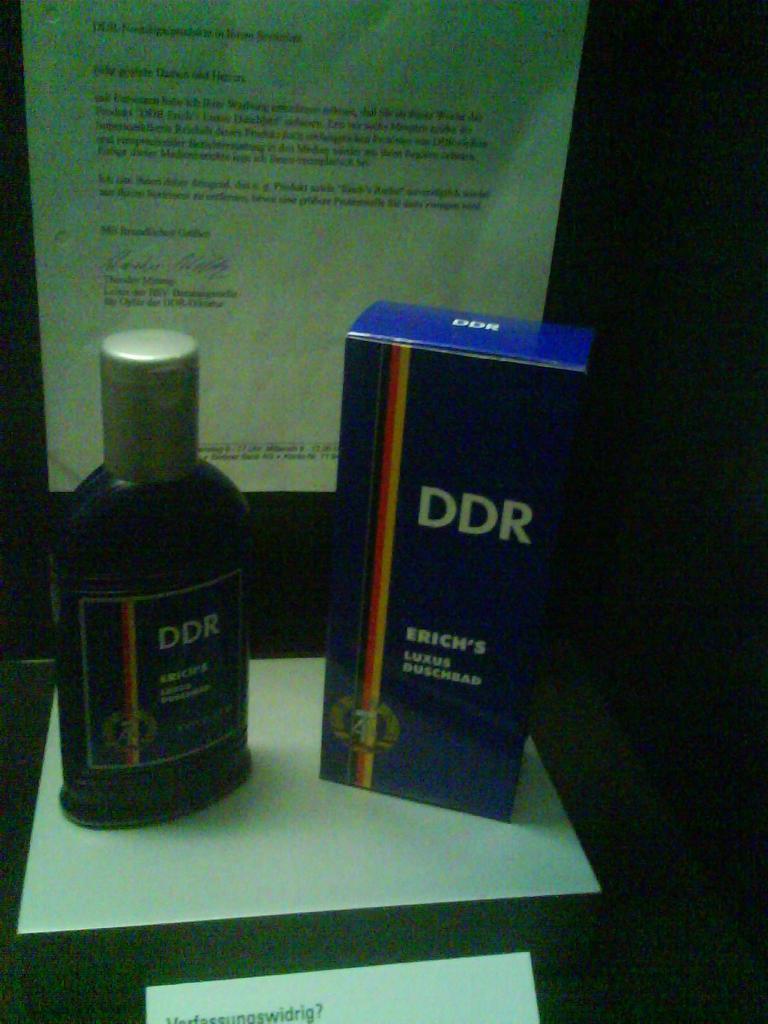What is the name of this bottle?
Your answer should be very brief. Ddr. 